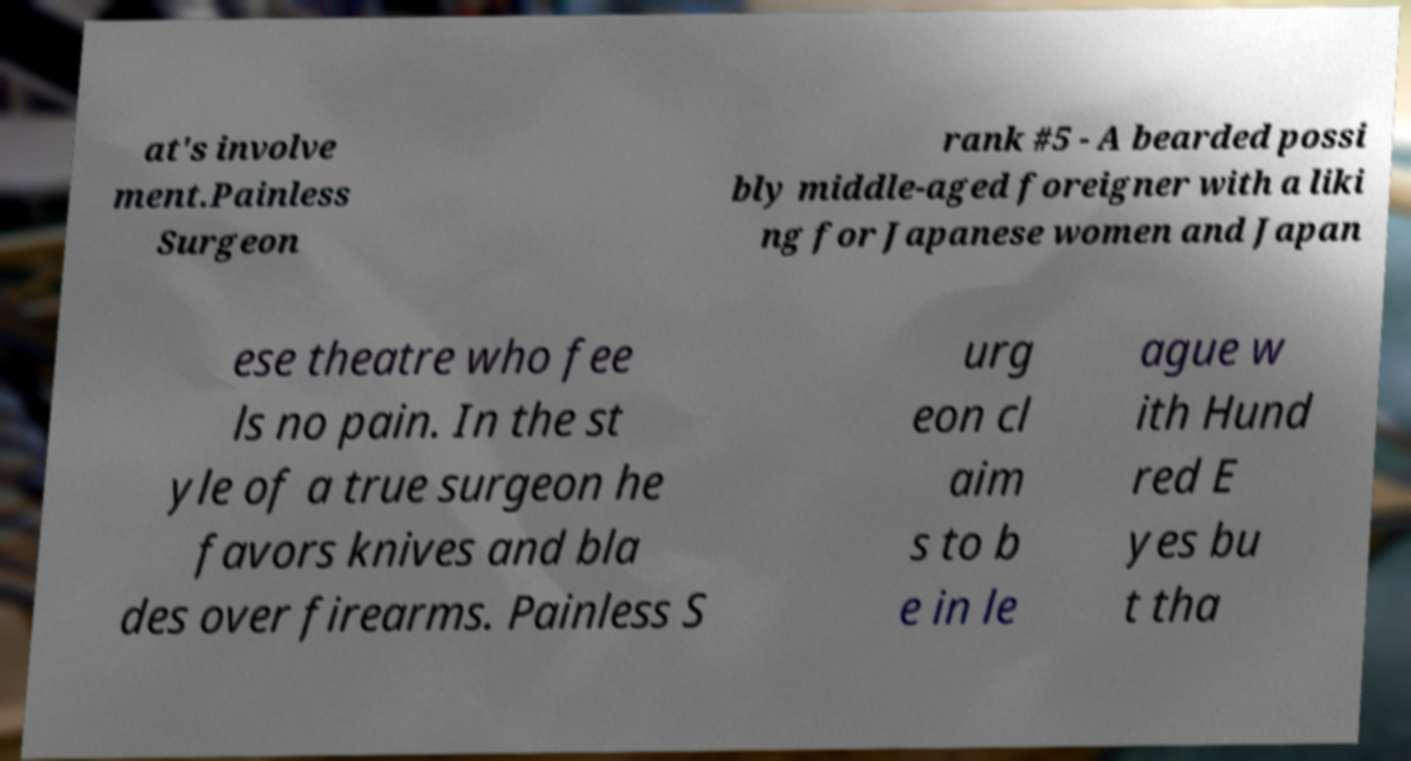Please identify and transcribe the text found in this image. at's involve ment.Painless Surgeon rank #5 - A bearded possi bly middle-aged foreigner with a liki ng for Japanese women and Japan ese theatre who fee ls no pain. In the st yle of a true surgeon he favors knives and bla des over firearms. Painless S urg eon cl aim s to b e in le ague w ith Hund red E yes bu t tha 